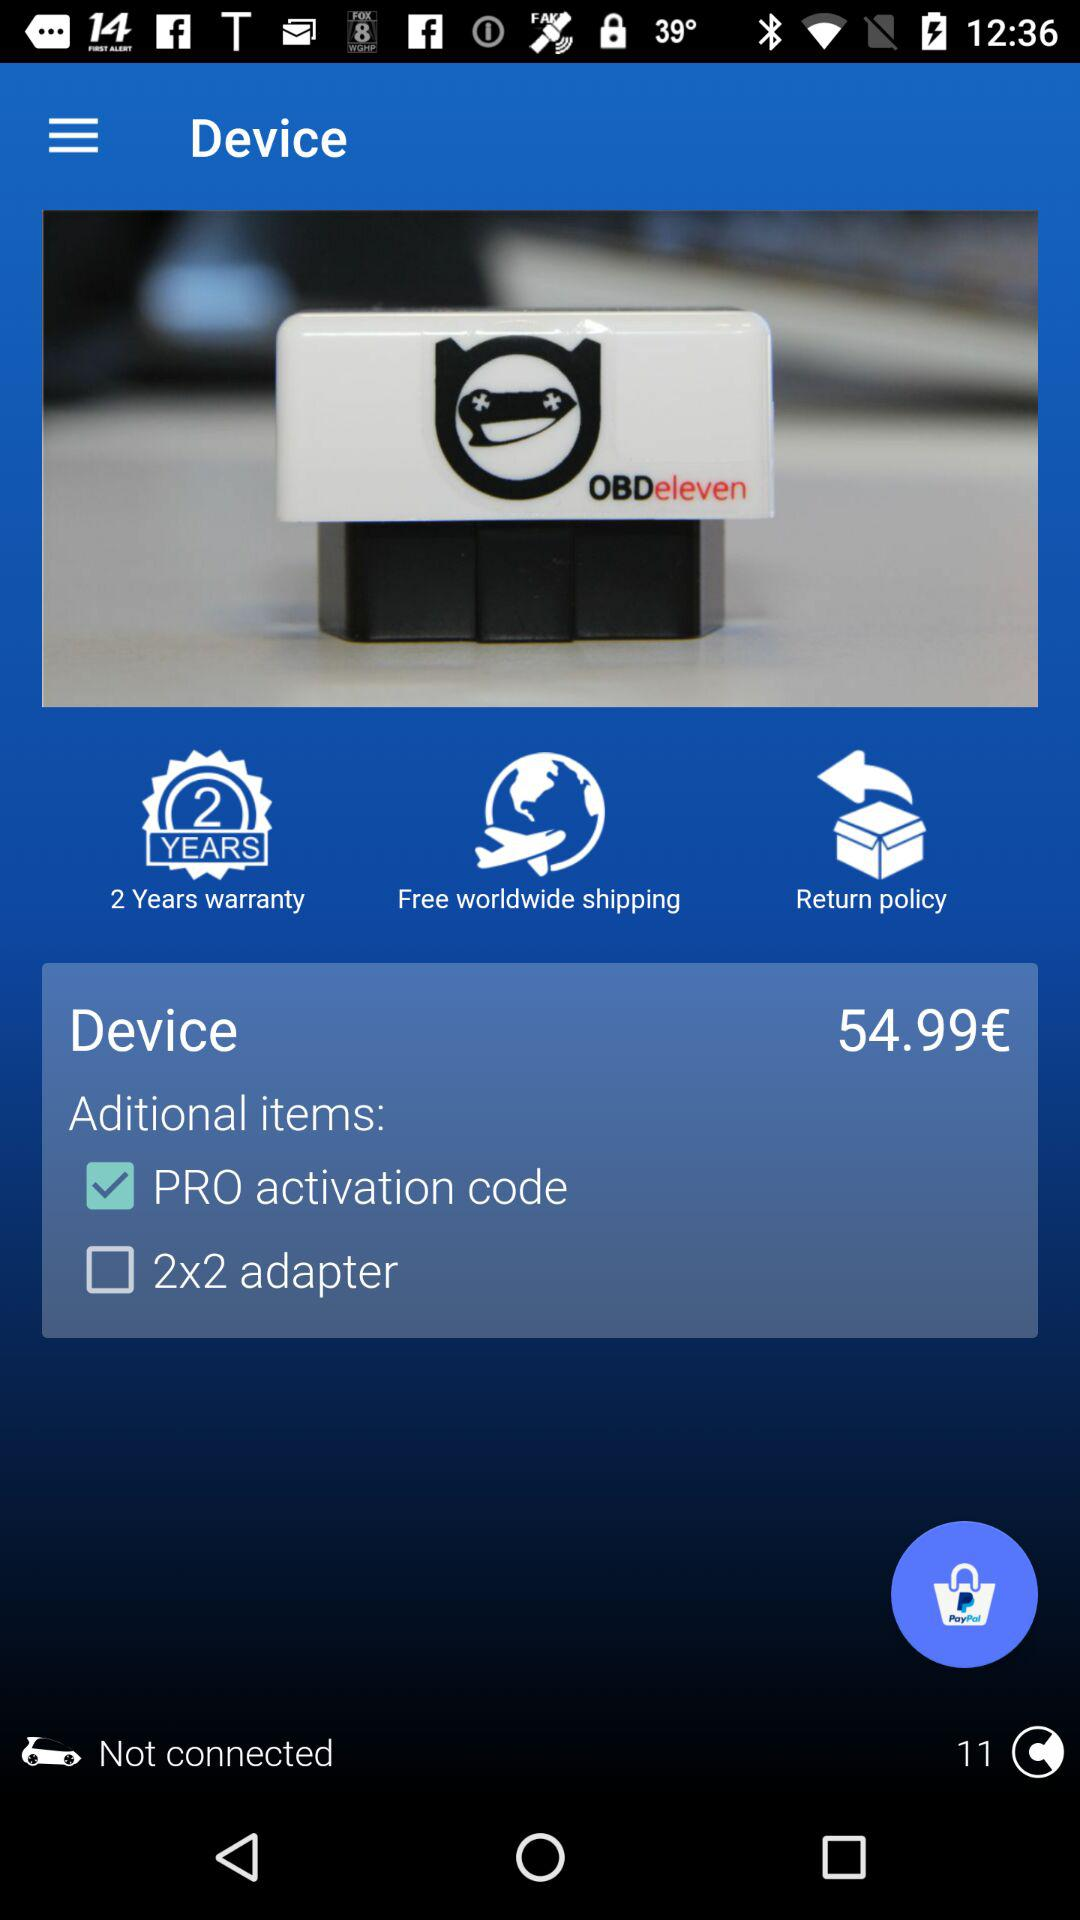What is the used currency for the price? The used currency is €‎. 